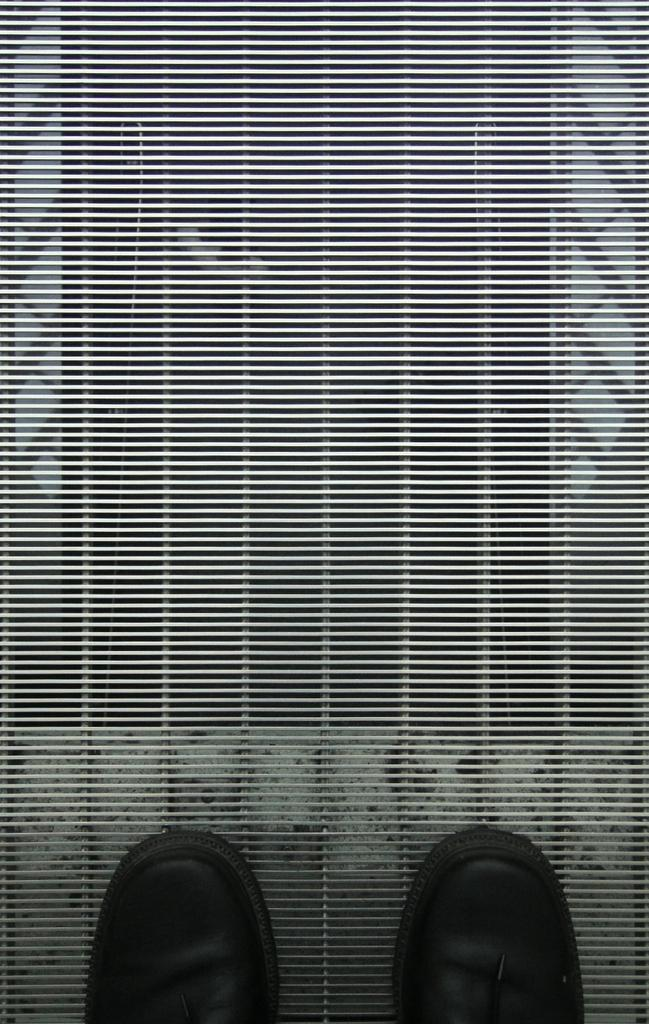What is the color scheme of the image? The picture is black and white. What objects are placed on the grills in the image? There are shoes on the grills in the image. How many slaves are depicted in the image? There are no slaves present in the image. What ideas are being discussed in the image? The image does not depict any ideas or discussions; it only shows shoes on grills. 